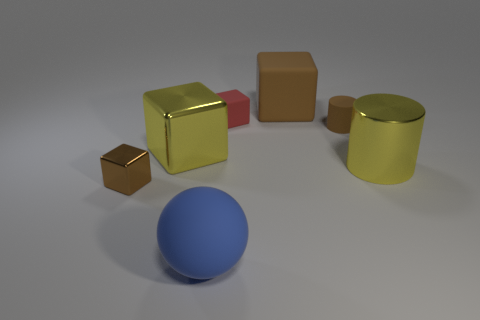There is a small block that is left of the large yellow shiny object that is left of the matte ball; what is its color? brown 